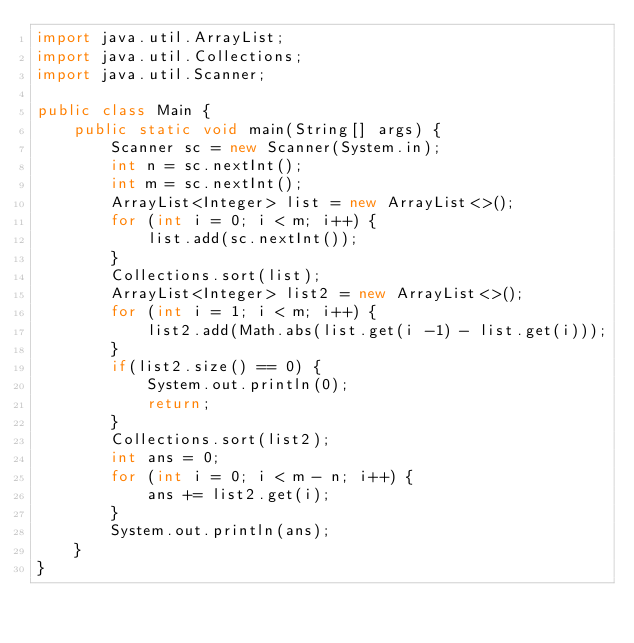<code> <loc_0><loc_0><loc_500><loc_500><_Java_>import java.util.ArrayList;
import java.util.Collections;
import java.util.Scanner;

public class Main {
    public static void main(String[] args) {
        Scanner sc = new Scanner(System.in);
        int n = sc.nextInt();
        int m = sc.nextInt();
        ArrayList<Integer> list = new ArrayList<>();
        for (int i = 0; i < m; i++) {
            list.add(sc.nextInt());
        }
        Collections.sort(list);
        ArrayList<Integer> list2 = new ArrayList<>();
        for (int i = 1; i < m; i++) {
            list2.add(Math.abs(list.get(i -1) - list.get(i)));
        }
        if(list2.size() == 0) {
            System.out.println(0);
            return;
        }
        Collections.sort(list2);
        int ans = 0;
        for (int i = 0; i < m - n; i++) {
            ans += list2.get(i);
        }
        System.out.println(ans);
    }
}</code> 